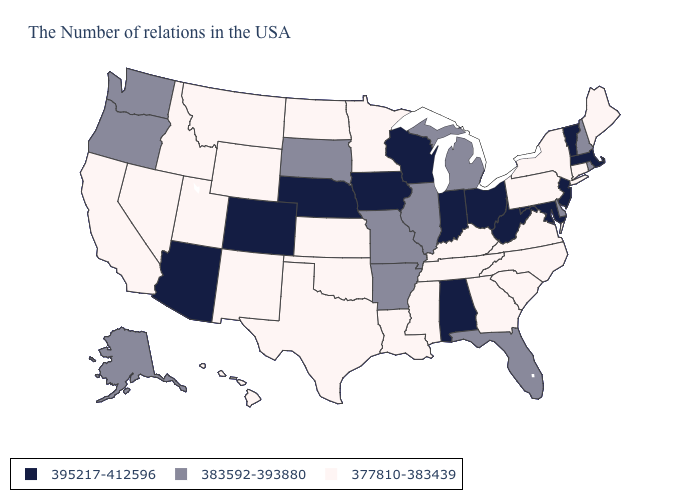Name the states that have a value in the range 377810-383439?
Answer briefly. Maine, Connecticut, New York, Pennsylvania, Virginia, North Carolina, South Carolina, Georgia, Kentucky, Tennessee, Mississippi, Louisiana, Minnesota, Kansas, Oklahoma, Texas, North Dakota, Wyoming, New Mexico, Utah, Montana, Idaho, Nevada, California, Hawaii. What is the value of Wisconsin?
Be succinct. 395217-412596. What is the value of Iowa?
Concise answer only. 395217-412596. What is the value of Arkansas?
Be succinct. 383592-393880. Does Tennessee have the same value as Washington?
Short answer required. No. Which states hav the highest value in the South?
Keep it brief. Maryland, West Virginia, Alabama. Name the states that have a value in the range 395217-412596?
Short answer required. Massachusetts, Vermont, New Jersey, Maryland, West Virginia, Ohio, Indiana, Alabama, Wisconsin, Iowa, Nebraska, Colorado, Arizona. Is the legend a continuous bar?
Quick response, please. No. Among the states that border Alabama , which have the highest value?
Concise answer only. Florida. What is the value of Idaho?
Quick response, please. 377810-383439. What is the lowest value in states that border Washington?
Be succinct. 377810-383439. Which states have the lowest value in the USA?
Quick response, please. Maine, Connecticut, New York, Pennsylvania, Virginia, North Carolina, South Carolina, Georgia, Kentucky, Tennessee, Mississippi, Louisiana, Minnesota, Kansas, Oklahoma, Texas, North Dakota, Wyoming, New Mexico, Utah, Montana, Idaho, Nevada, California, Hawaii. What is the value of Alabama?
Be succinct. 395217-412596. Among the states that border Iowa , which have the highest value?
Give a very brief answer. Wisconsin, Nebraska. How many symbols are there in the legend?
Give a very brief answer. 3. 